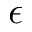Convert formula to latex. <formula><loc_0><loc_0><loc_500><loc_500>\epsilon</formula> 